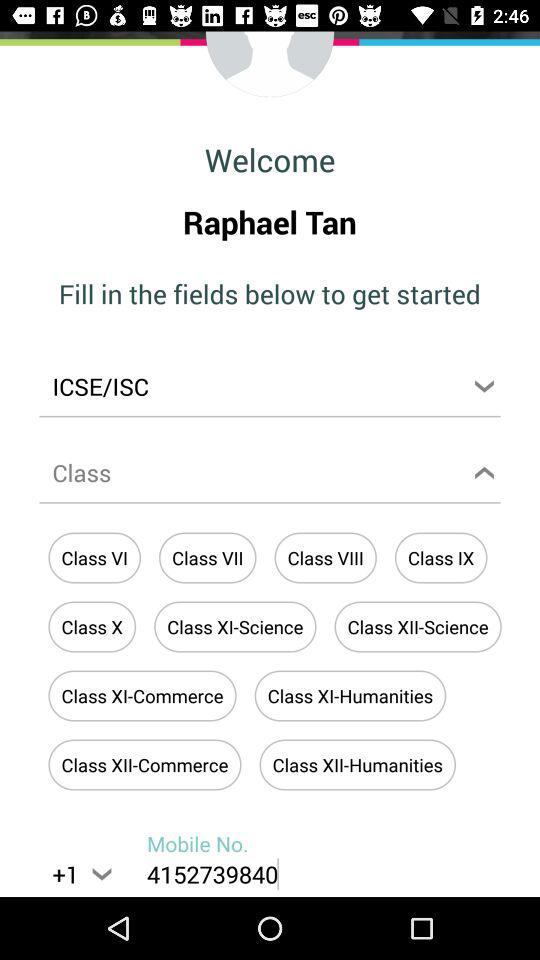What is the user name? The user name is Raphael Tan. 